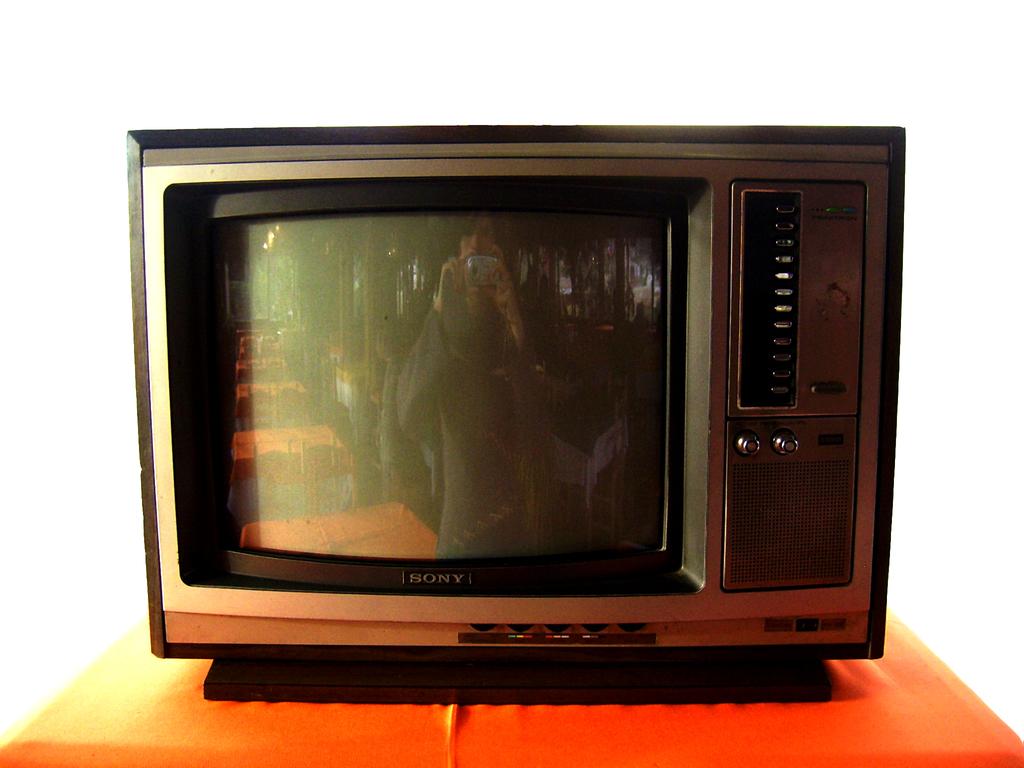What tv is that?
Ensure brevity in your answer.  Sony. 